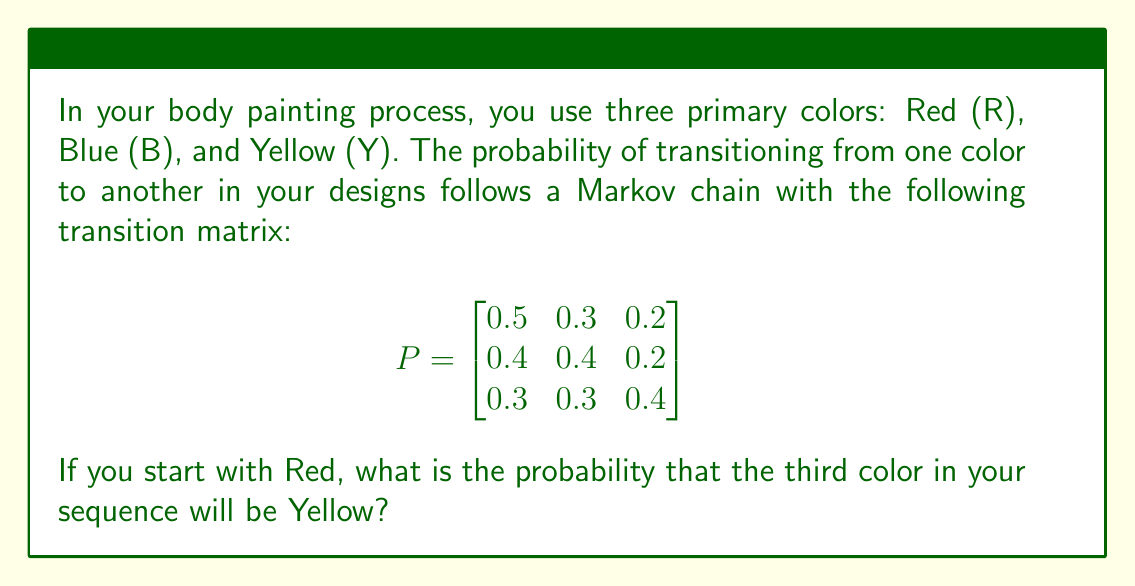What is the answer to this math problem? To solve this problem, we need to use the properties of Markov chains and matrix multiplication. Let's approach this step-by-step:

1) The given transition matrix $P$ represents the probabilities of moving from one color to another in a single step.

2) We want to find the probability of being in Yellow (Y) after two transitions, starting from Red (R).

3) This can be calculated by multiplying the initial state vector with the transition matrix twice.

4) The initial state vector for starting with Red is $[1, 0, 0]$.

5) Let's perform the calculations:

   Step 1: $[1, 0, 0] \cdot P = [0.5, 0.3, 0.2]$

   Step 2: $[0.5, 0.3, 0.2] \cdot P$

6) We can calculate this multiplication:

   $$[0.5, 0.3, 0.2] \cdot \begin{bmatrix}
   0.5 & 0.3 & 0.2 \\
   0.4 & 0.4 & 0.2 \\
   0.3 & 0.3 & 0.4
   \end{bmatrix}$$

   $= [0.5(0.5) + 0.3(0.4) + 0.2(0.3), 0.5(0.3) + 0.3(0.4) + 0.2(0.3), 0.5(0.2) + 0.3(0.2) + 0.2(0.4)]$

   $= [0.25 + 0.12 + 0.06, 0.15 + 0.12 + 0.06, 0.1 + 0.06 + 0.08]$

   $= [0.43, 0.33, 0.24]$

7) The probability we're interested in is the last element of this resulting vector, which represents the probability of being in state Y (Yellow) after two transitions.

Therefore, the probability of the third color in the sequence being Yellow, given that we started with Red, is 0.24 or 24%.
Answer: 0.24 